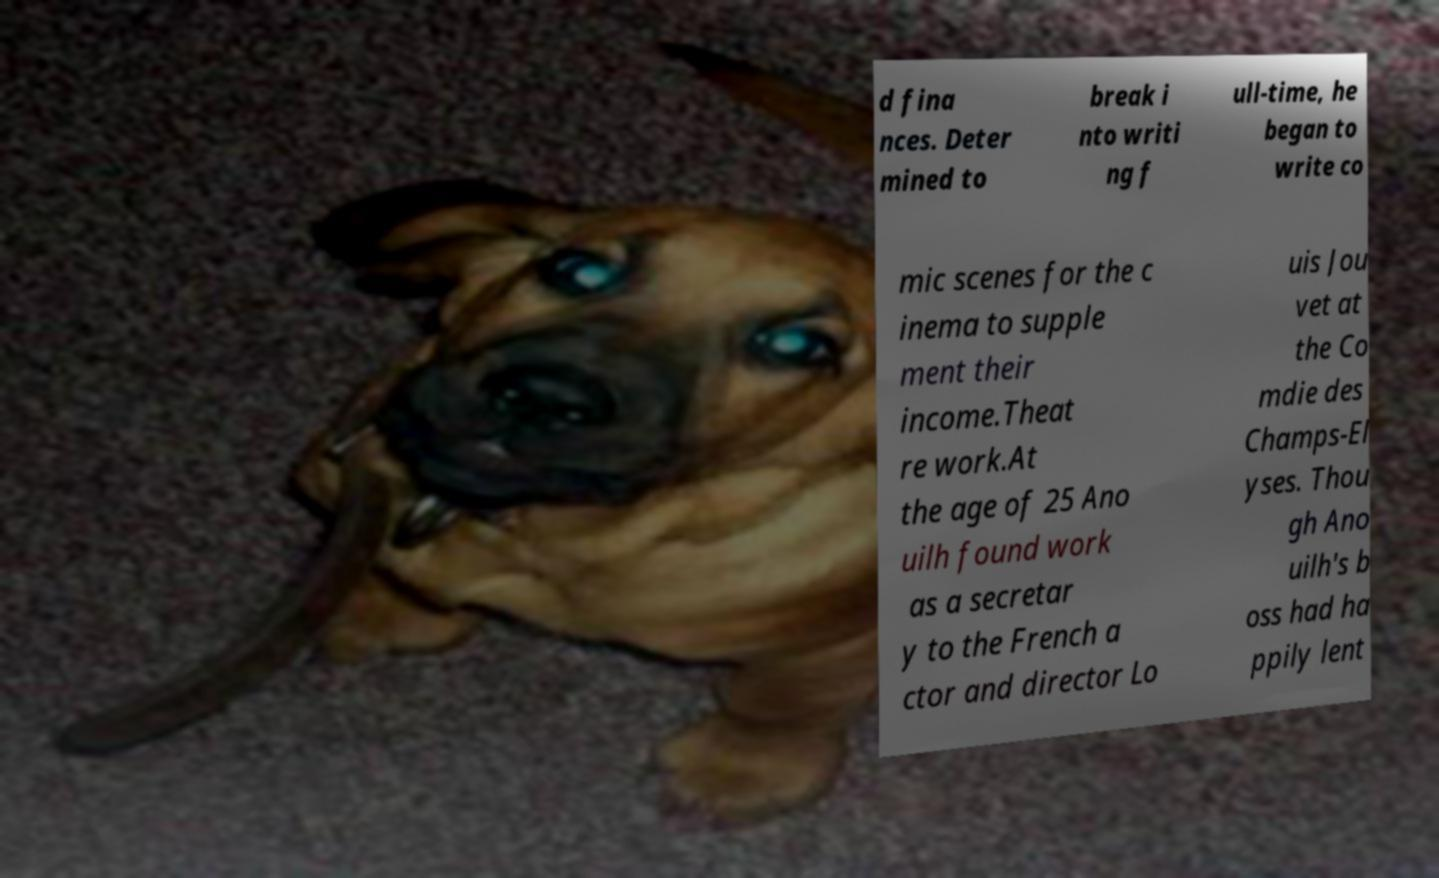There's text embedded in this image that I need extracted. Can you transcribe it verbatim? d fina nces. Deter mined to break i nto writi ng f ull-time, he began to write co mic scenes for the c inema to supple ment their income.Theat re work.At the age of 25 Ano uilh found work as a secretar y to the French a ctor and director Lo uis Jou vet at the Co mdie des Champs-El yses. Thou gh Ano uilh's b oss had ha ppily lent 